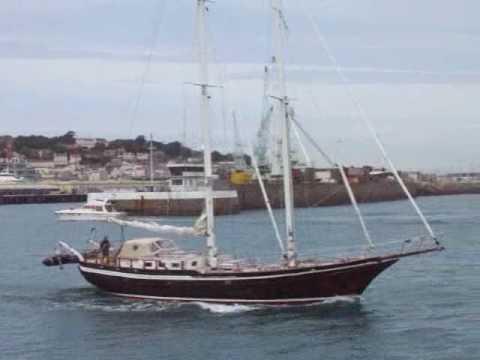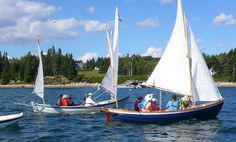The first image is the image on the left, the second image is the image on the right. For the images shown, is this caption "People are in two sailboats in the water in one of the images." true? Answer yes or no. Yes. The first image is the image on the left, the second image is the image on the right. Analyze the images presented: Is the assertion "One image shows at least one sailboat with unfurled sails, and the other image shows a boat with furled sails that is not next to a dock." valid? Answer yes or no. Yes. 